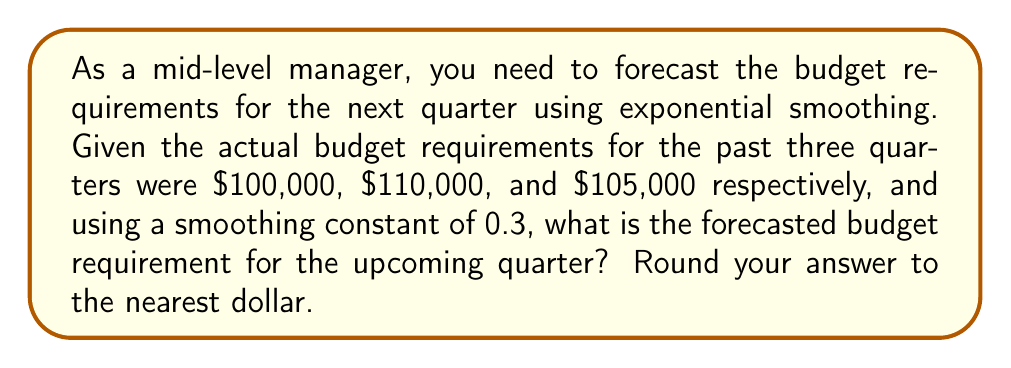Give your solution to this math problem. To solve this problem using exponential smoothing, we'll follow these steps:

1. The exponential smoothing formula is:
   $$F_t = \alpha A_{t-1} + (1-\alpha)F_{t-1}$$
   Where:
   $F_t$ is the forecast for period t
   $\alpha$ is the smoothing constant (0.3 in this case)
   $A_{t-1}$ is the actual value for the previous period
   $F_{t-1}$ is the previous forecast

2. We need to start with an initial forecast. Since we don't have one, we'll use the first actual value as our initial forecast:
   $F_1 = 100,000$

3. Calculate the forecast for the second quarter:
   $$F_2 = 0.3(100,000) + 0.7(100,000) = 100,000$$

4. Calculate the forecast for the third quarter:
   $$F_3 = 0.3(110,000) + 0.7(100,000) = 103,000$$

5. Calculate the forecast for the fourth quarter (our target):
   $$F_4 = 0.3(105,000) + 0.7(103,000) = 103,600$$

6. Rounding to the nearest dollar:
   $103,600

Therefore, the forecasted budget requirement for the upcoming quarter is $103,600.
Answer: $103,600 